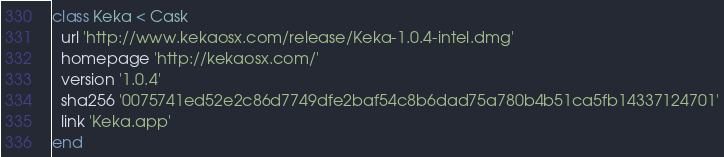Convert code to text. <code><loc_0><loc_0><loc_500><loc_500><_Ruby_>class Keka < Cask
  url 'http://www.kekaosx.com/release/Keka-1.0.4-intel.dmg'
  homepage 'http://kekaosx.com/'
  version '1.0.4'
  sha256 '0075741ed52e2c86d7749dfe2baf54c8b6dad75a780b4b51ca5fb14337124701'
  link 'Keka.app'
end
</code> 